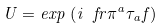Convert formula to latex. <formula><loc_0><loc_0><loc_500><loc_500>U = { e x p } \, \left ( i \ f r { \pi ^ { a } \tau _ { a } } { f } \right )</formula> 